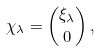<formula> <loc_0><loc_0><loc_500><loc_500>\chi _ { \lambda } = { \xi _ { \lambda } \choose 0 } \, ,</formula> 